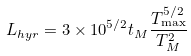<formula> <loc_0><loc_0><loc_500><loc_500>L _ { h y r } = 3 \times 1 0 ^ { 5 / 2 } t _ { M } \frac { T _ { \max } ^ { 5 / 2 } } { T _ { M } ^ { 2 } }</formula> 